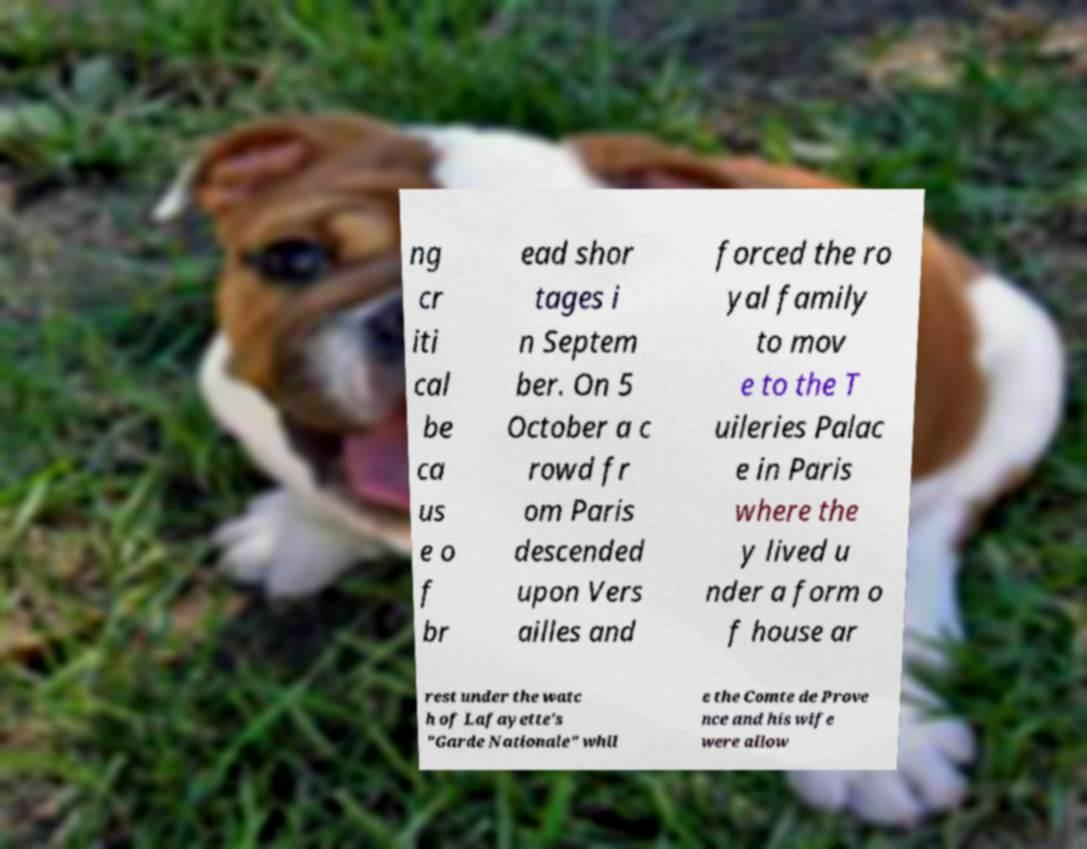Please read and relay the text visible in this image. What does it say? ng cr iti cal be ca us e o f br ead shor tages i n Septem ber. On 5 October a c rowd fr om Paris descended upon Vers ailles and forced the ro yal family to mov e to the T uileries Palac e in Paris where the y lived u nder a form o f house ar rest under the watc h of Lafayette's "Garde Nationale" whil e the Comte de Prove nce and his wife were allow 